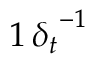<formula> <loc_0><loc_0><loc_500><loc_500>1 \, { \delta _ { t } } ^ { - 1 }</formula> 